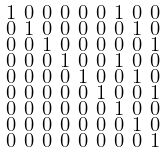Convert formula to latex. <formula><loc_0><loc_0><loc_500><loc_500>\begin{smallmatrix} 1 & 0 & 0 & 0 & 0 & 0 & 1 & 0 & 0 \\ 0 & 1 & 0 & 0 & 0 & 0 & 0 & 1 & 0 \\ 0 & 0 & 1 & 0 & 0 & 0 & 0 & 0 & 1 \\ 0 & 0 & 0 & 1 & 0 & 0 & 1 & 0 & 0 \\ 0 & 0 & 0 & 0 & 1 & 0 & 0 & 1 & 0 \\ 0 & 0 & 0 & 0 & 0 & 1 & 0 & 0 & 1 \\ 0 & 0 & 0 & 0 & 0 & 0 & 1 & 0 & 0 \\ 0 & 0 & 0 & 0 & 0 & 0 & 0 & 1 & 0 \\ 0 & 0 & 0 & 0 & 0 & 0 & 0 & 0 & 1 \end{smallmatrix}</formula> 